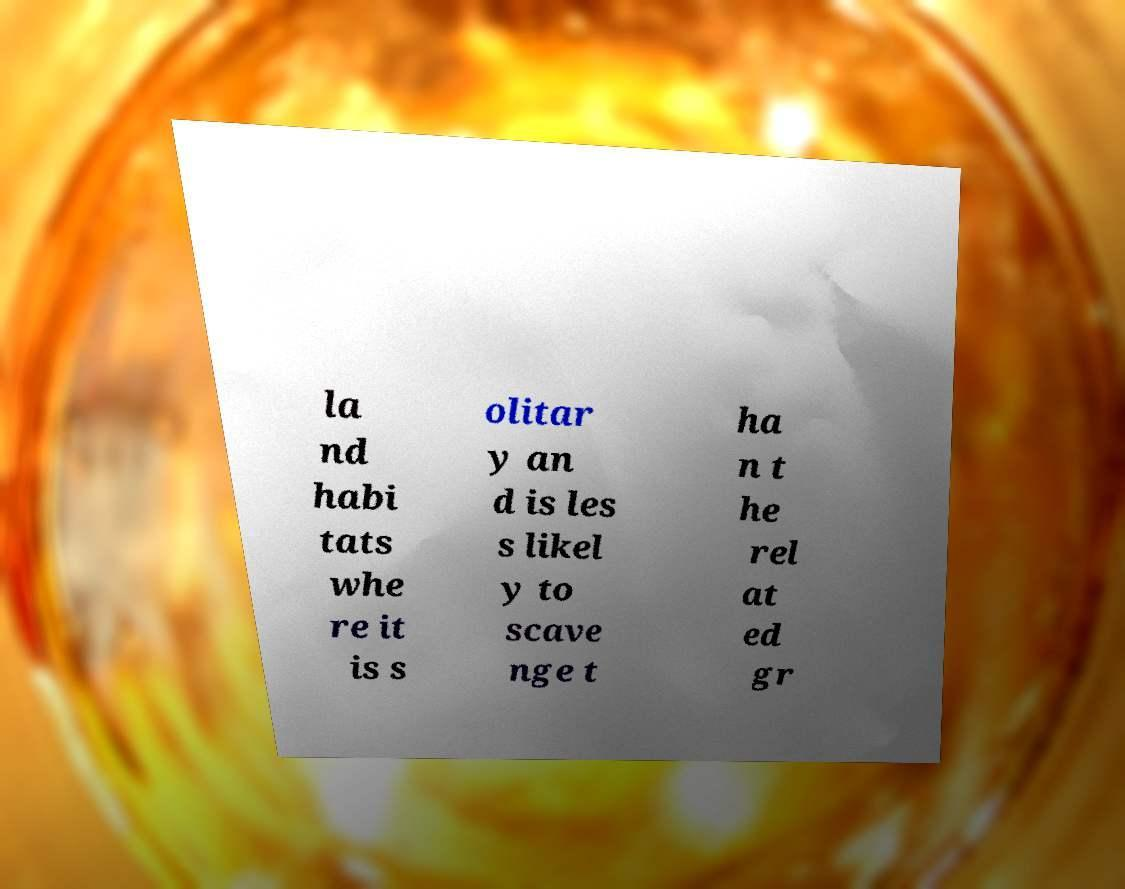Please read and relay the text visible in this image. What does it say? la nd habi tats whe re it is s olitar y an d is les s likel y to scave nge t ha n t he rel at ed gr 